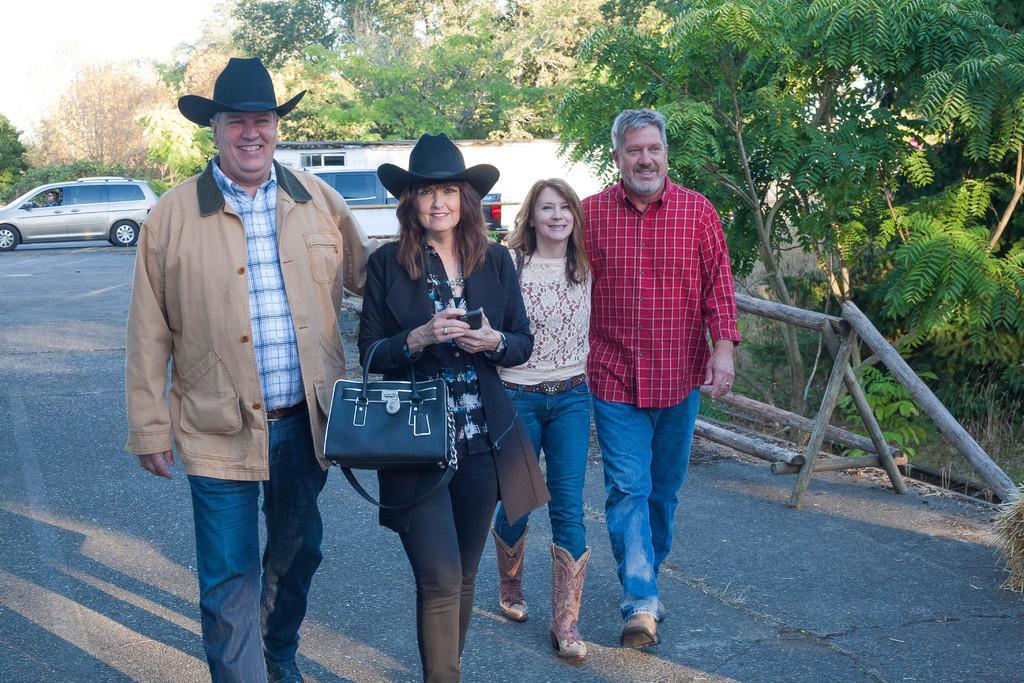Could you give a brief overview of what you see in this image? In the image there are four people who are walking on the road, two men and two women in the background there are lot of trees, sky, a car,road, shadow of the people and also a truck. 